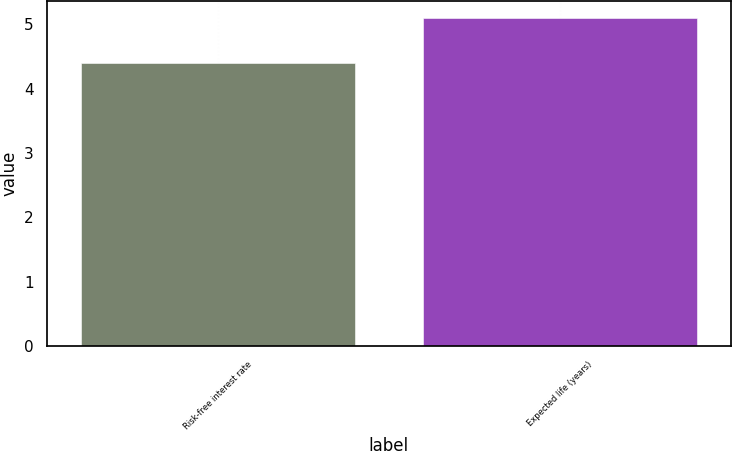Convert chart. <chart><loc_0><loc_0><loc_500><loc_500><bar_chart><fcel>Risk-free interest rate<fcel>Expected life (years)<nl><fcel>4.4<fcel>5.1<nl></chart> 